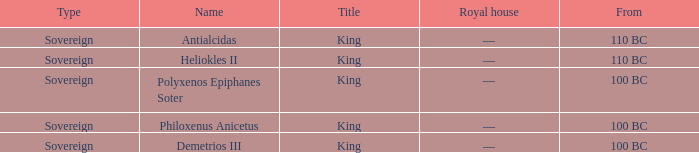Which royal house corresponds to Polyxenos Epiphanes Soter? —. 